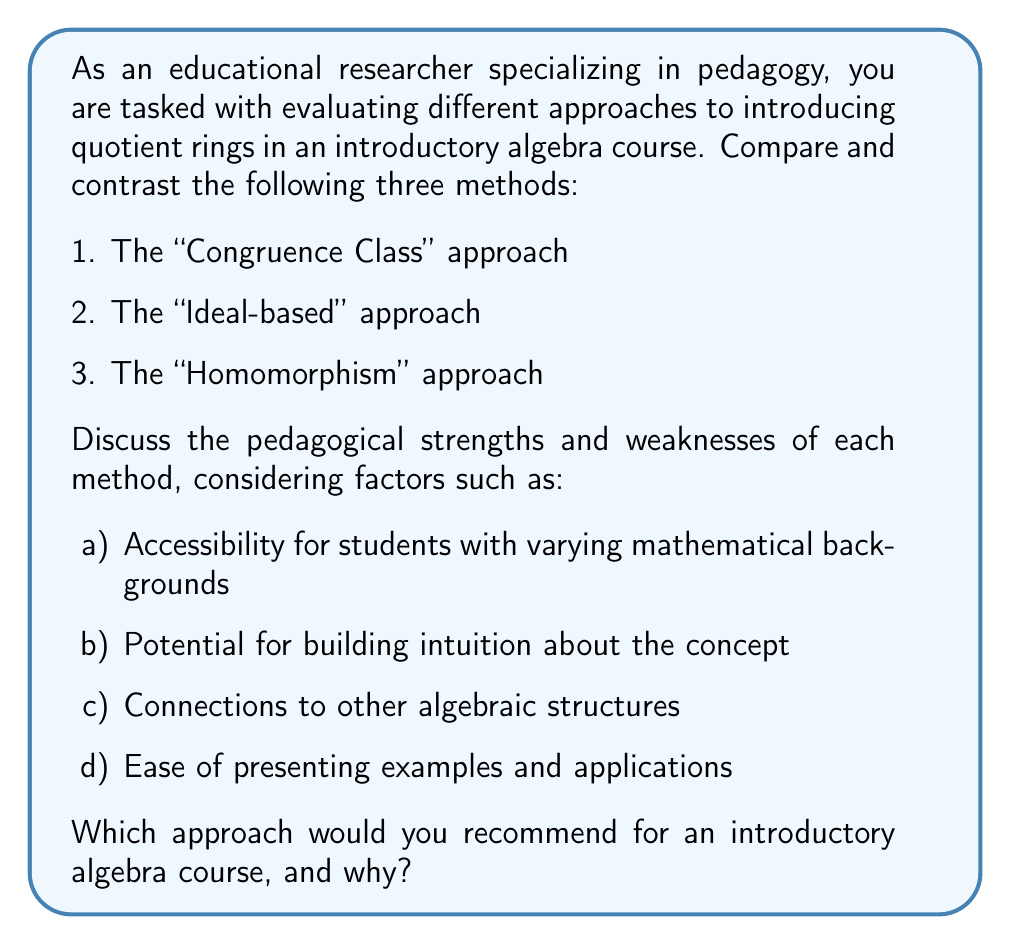Solve this math problem. To answer this question, we need to analyze each approach from a pedagogical perspective:

1. The "Congruence Class" approach:
   This method introduces quotient rings by drawing parallels with modular arithmetic in the integers.

   Strengths:
   a) Accessibility: Students are often familiar with modular arithmetic, making this approach more relatable.
   b) Intuition: It builds on the concrete idea of remainders, which can be easier to grasp.
   c) Connections: It clearly connects to number theory and group theory concepts.

   Weaknesses:
   a) Limited scope: May not generalize well to more abstract ring structures.
   b) Potential confusion: Students might struggle to distinguish between cosets and congruence classes.

2. The "Ideal-based" approach:
   This method defines quotient rings using ideals as the fundamental building blocks.

   Strengths:
   a) Rigor: Provides a mathematically precise definition.
   b) Connections: Reinforces the importance of ideals in ring theory.
   c) Generality: Applies to all types of rings and ideals.

   Weaknesses:
   a) Accessibility: May be challenging for students who are still grappling with the concept of ideals.
   b) Abstraction: Can be difficult to visualize or relate to concrete examples initially.

3. The "Homomorphism" approach:
   This method introduces quotient rings through the lens of ring homomorphisms and their kernels.

   Strengths:
   a) Connections: Emphasizes the relationship between quotient rings and homomorphisms.
   b) Intuition: Builds on the idea of "collapsing" elements, which can be visually represented.
   c) Generality: Applies to various algebraic structures beyond rings.

   Weaknesses:
   a) Complexity: Requires understanding of homomorphisms, which may be challenging for some students.
   b) Abstraction: The connection to concrete examples may not be immediately apparent.

Considering these factors, the recommended approach for an introductory algebra course would be the "Congruence Class" approach. This method offers the best balance of accessibility and intuition-building for students new to abstract algebra. It leverages their prior knowledge of modular arithmetic, providing a concrete foundation upon which to build more abstract concepts.

However, it's important to note that a comprehensive understanding of quotient rings would ultimately require exposure to all three approaches. The congruence class method can serve as an entry point, with the ideal-based and homomorphism approaches introduced later to provide a more complete and rigorous treatment of the topic.

To implement this effectively:

1. Begin with familiar examples of modular arithmetic in $\mathbb{Z}$.
2. Generalize to other rings, showing how congruence classes form equivalence relations.
3. Introduce the algebraic structure of these classes, forming the quotient ring.
4. Later, connect this to ideals and homomorphisms, showing how the initial intuition extends to more abstract concepts.

This approach allows for a gradual increase in abstraction, supporting students' conceptual development while maintaining connections to concrete examples throughout the learning process.
Answer: The recommended approach for introducing quotient rings in an introductory algebra course is the "Congruence Class" approach. This method offers the best balance of accessibility and intuition-building for beginners, leveraging students' prior knowledge of modular arithmetic. However, a comprehensive understanding should ultimately incorporate all three approaches (Congruence Class, Ideal-based, and Homomorphism) as the course progresses, allowing for a gradual increase in abstraction and rigor. 